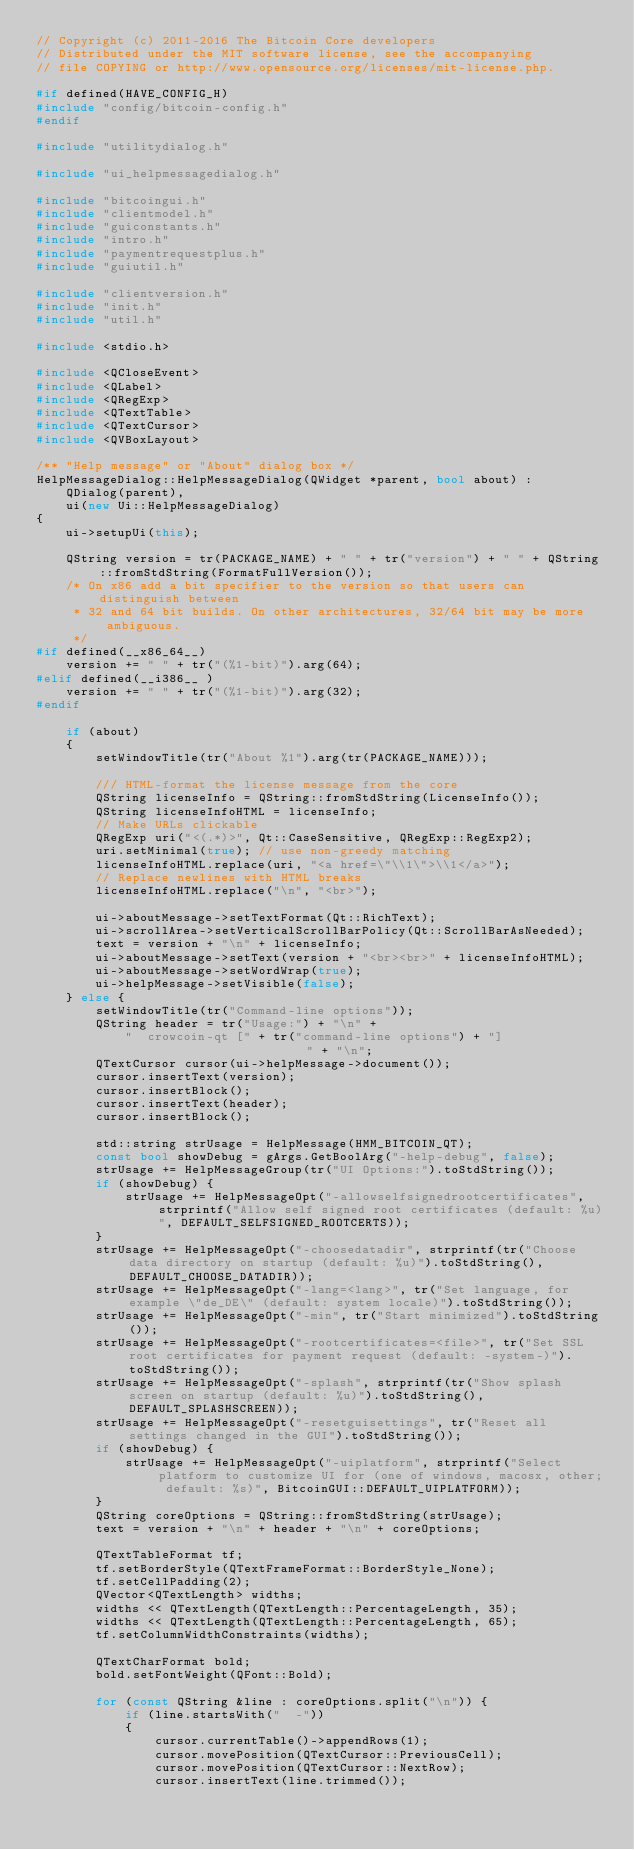Convert code to text. <code><loc_0><loc_0><loc_500><loc_500><_C++_>// Copyright (c) 2011-2016 The Bitcoin Core developers
// Distributed under the MIT software license, see the accompanying
// file COPYING or http://www.opensource.org/licenses/mit-license.php.

#if defined(HAVE_CONFIG_H)
#include "config/bitcoin-config.h"
#endif

#include "utilitydialog.h"

#include "ui_helpmessagedialog.h"

#include "bitcoingui.h"
#include "clientmodel.h"
#include "guiconstants.h"
#include "intro.h"
#include "paymentrequestplus.h"
#include "guiutil.h"

#include "clientversion.h"
#include "init.h"
#include "util.h"

#include <stdio.h>

#include <QCloseEvent>
#include <QLabel>
#include <QRegExp>
#include <QTextTable>
#include <QTextCursor>
#include <QVBoxLayout>

/** "Help message" or "About" dialog box */
HelpMessageDialog::HelpMessageDialog(QWidget *parent, bool about) :
    QDialog(parent),
    ui(new Ui::HelpMessageDialog)
{
    ui->setupUi(this);

    QString version = tr(PACKAGE_NAME) + " " + tr("version") + " " + QString::fromStdString(FormatFullVersion());
    /* On x86 add a bit specifier to the version so that users can distinguish between
     * 32 and 64 bit builds. On other architectures, 32/64 bit may be more ambiguous.
     */
#if defined(__x86_64__)
    version += " " + tr("(%1-bit)").arg(64);
#elif defined(__i386__ )
    version += " " + tr("(%1-bit)").arg(32);
#endif

    if (about)
    {
        setWindowTitle(tr("About %1").arg(tr(PACKAGE_NAME)));

        /// HTML-format the license message from the core
        QString licenseInfo = QString::fromStdString(LicenseInfo());
        QString licenseInfoHTML = licenseInfo;
        // Make URLs clickable
        QRegExp uri("<(.*)>", Qt::CaseSensitive, QRegExp::RegExp2);
        uri.setMinimal(true); // use non-greedy matching
        licenseInfoHTML.replace(uri, "<a href=\"\\1\">\\1</a>");
        // Replace newlines with HTML breaks
        licenseInfoHTML.replace("\n", "<br>");

        ui->aboutMessage->setTextFormat(Qt::RichText);
        ui->scrollArea->setVerticalScrollBarPolicy(Qt::ScrollBarAsNeeded);
        text = version + "\n" + licenseInfo;
        ui->aboutMessage->setText(version + "<br><br>" + licenseInfoHTML);
        ui->aboutMessage->setWordWrap(true);
        ui->helpMessage->setVisible(false);
    } else {
        setWindowTitle(tr("Command-line options"));
        QString header = tr("Usage:") + "\n" +
            "  crowcoin-qt [" + tr("command-line options") + "]                     " + "\n";
        QTextCursor cursor(ui->helpMessage->document());
        cursor.insertText(version);
        cursor.insertBlock();
        cursor.insertText(header);
        cursor.insertBlock();

        std::string strUsage = HelpMessage(HMM_BITCOIN_QT);
        const bool showDebug = gArgs.GetBoolArg("-help-debug", false);
        strUsage += HelpMessageGroup(tr("UI Options:").toStdString());
        if (showDebug) {
            strUsage += HelpMessageOpt("-allowselfsignedrootcertificates", strprintf("Allow self signed root certificates (default: %u)", DEFAULT_SELFSIGNED_ROOTCERTS));
        }
        strUsage += HelpMessageOpt("-choosedatadir", strprintf(tr("Choose data directory on startup (default: %u)").toStdString(), DEFAULT_CHOOSE_DATADIR));
        strUsage += HelpMessageOpt("-lang=<lang>", tr("Set language, for example \"de_DE\" (default: system locale)").toStdString());
        strUsage += HelpMessageOpt("-min", tr("Start minimized").toStdString());
        strUsage += HelpMessageOpt("-rootcertificates=<file>", tr("Set SSL root certificates for payment request (default: -system-)").toStdString());
        strUsage += HelpMessageOpt("-splash", strprintf(tr("Show splash screen on startup (default: %u)").toStdString(), DEFAULT_SPLASHSCREEN));
        strUsage += HelpMessageOpt("-resetguisettings", tr("Reset all settings changed in the GUI").toStdString());
        if (showDebug) {
            strUsage += HelpMessageOpt("-uiplatform", strprintf("Select platform to customize UI for (one of windows, macosx, other; default: %s)", BitcoinGUI::DEFAULT_UIPLATFORM));
        }
        QString coreOptions = QString::fromStdString(strUsage);
        text = version + "\n" + header + "\n" + coreOptions;

        QTextTableFormat tf;
        tf.setBorderStyle(QTextFrameFormat::BorderStyle_None);
        tf.setCellPadding(2);
        QVector<QTextLength> widths;
        widths << QTextLength(QTextLength::PercentageLength, 35);
        widths << QTextLength(QTextLength::PercentageLength, 65);
        tf.setColumnWidthConstraints(widths);

        QTextCharFormat bold;
        bold.setFontWeight(QFont::Bold);

        for (const QString &line : coreOptions.split("\n")) {
            if (line.startsWith("  -"))
            {
                cursor.currentTable()->appendRows(1);
                cursor.movePosition(QTextCursor::PreviousCell);
                cursor.movePosition(QTextCursor::NextRow);
                cursor.insertText(line.trimmed());</code> 